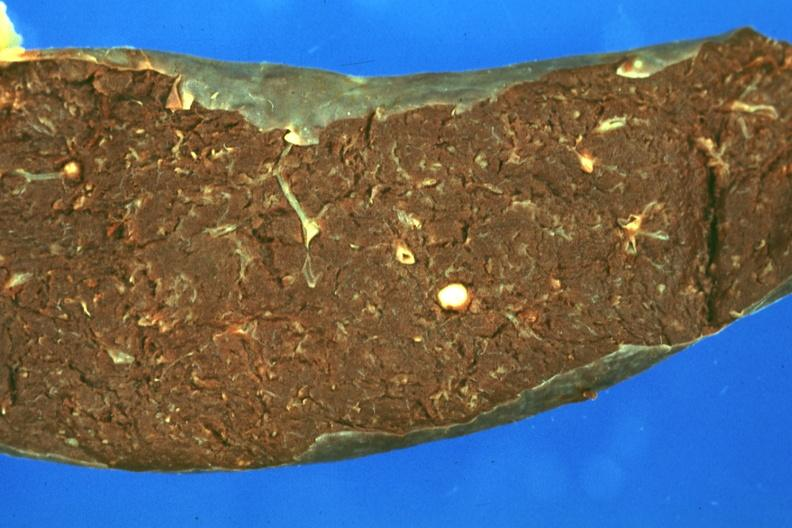what does this image show?
Answer the question using a single word or phrase. Fixed tissue but color not too bad single typical lesion 